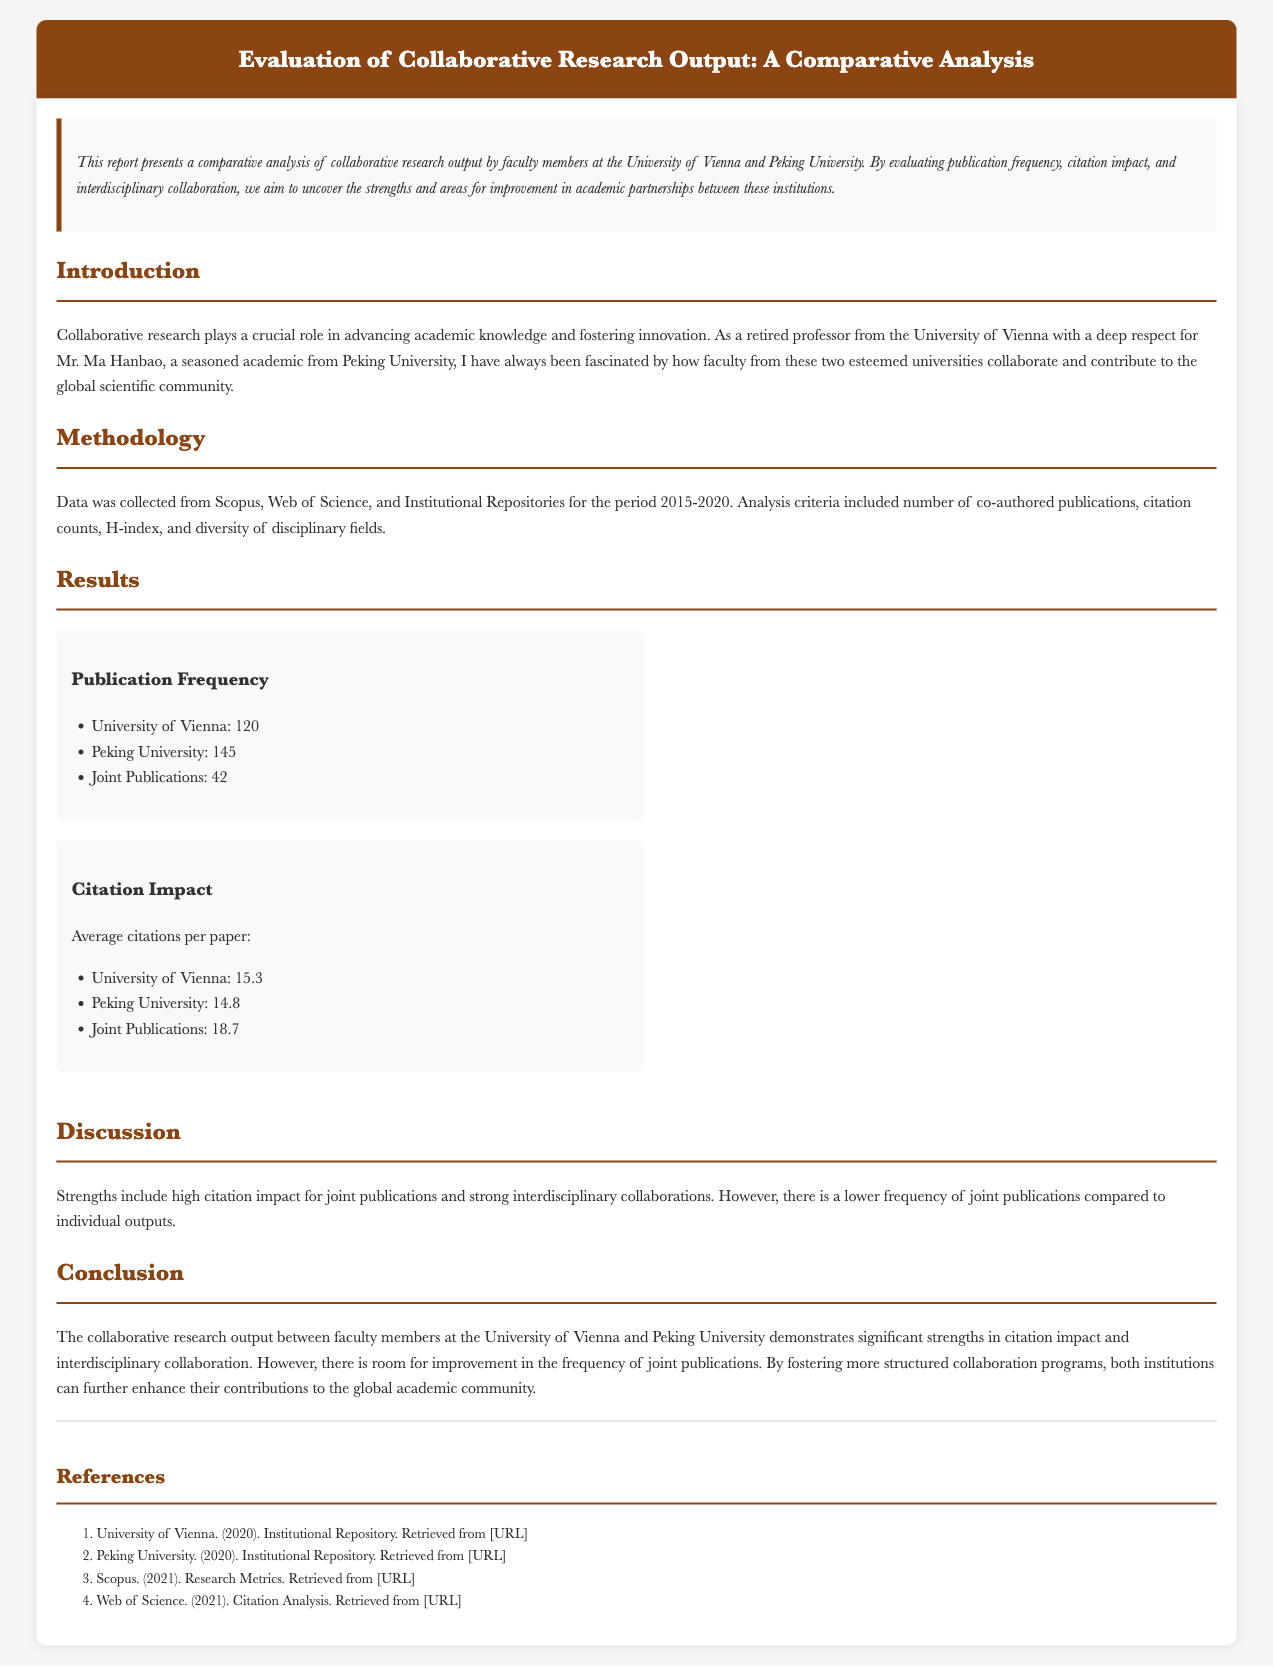What is the publication frequency for the University of Vienna? The publication frequency for the University of Vienna is mentioned as 120.
Answer: 120 How many joint publications were recorded between the two universities? The document states that there were 42 joint publications.
Answer: 42 What is the average citation impact for joint publications? The average citations per paper for joint publications is 18.7, as per the results section.
Answer: 18.7 Which university had a higher number of total publications? The document indicates that Peking University had 145 publications, which is higher than the 120 from the University of Vienna.
Answer: Peking University What strengths are identified in the discussion section? The strengths mentioned include high citation impact for joint publications and strong interdisciplinary collaborations.
Answer: High citation impact and strong interdisciplinary collaborations 